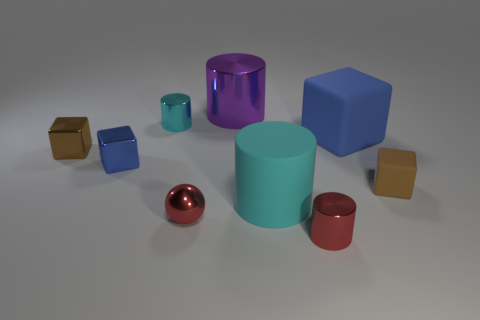What material is the cube that is the same color as the tiny matte thing?
Ensure brevity in your answer.  Metal. Are there any other purple objects of the same shape as the big shiny object?
Offer a terse response. No. Do the red sphere and the tiny block that is to the right of the tiny cyan thing have the same material?
Ensure brevity in your answer.  No. Is there a rubber cylinder of the same color as the big matte block?
Provide a succinct answer. No. What number of other objects are the same material as the tiny cyan cylinder?
Offer a terse response. 5. There is a big metallic cylinder; is it the same color as the small object behind the big blue rubber object?
Your response must be concise. No. Are there more purple metal cylinders in front of the cyan metallic cylinder than cyan rubber cylinders?
Ensure brevity in your answer.  No. How many cyan objects are to the right of the red thing right of the red object that is left of the big purple object?
Offer a terse response. 0. Does the large matte object that is behind the small brown rubber cube have the same shape as the cyan shiny object?
Your answer should be compact. No. There is a tiny red sphere that is in front of the large cyan thing; what is it made of?
Your answer should be very brief. Metal. 